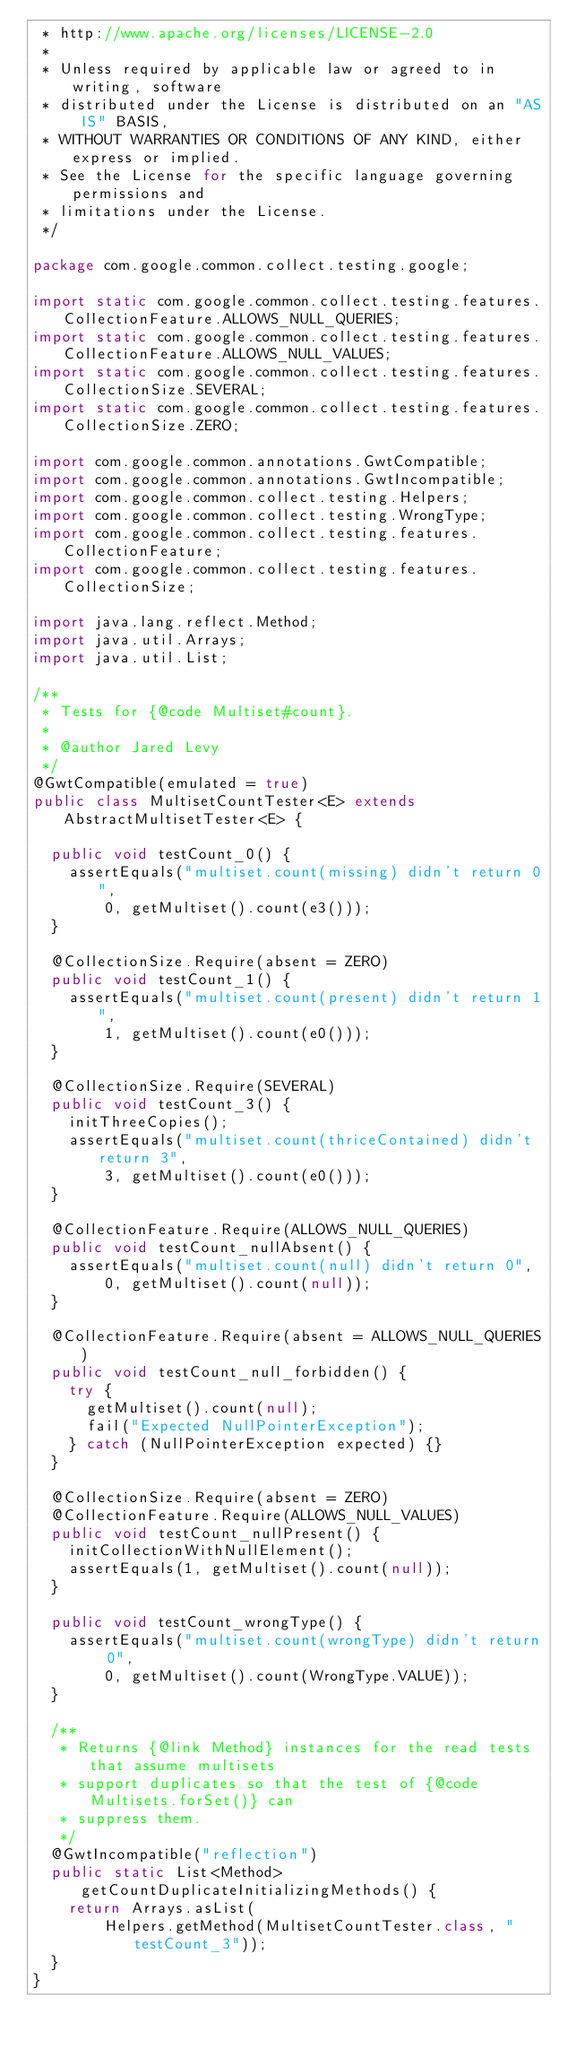Convert code to text. <code><loc_0><loc_0><loc_500><loc_500><_Java_> * http://www.apache.org/licenses/LICENSE-2.0
 *
 * Unless required by applicable law or agreed to in writing, software
 * distributed under the License is distributed on an "AS IS" BASIS,
 * WITHOUT WARRANTIES OR CONDITIONS OF ANY KIND, either express or implied.
 * See the License for the specific language governing permissions and
 * limitations under the License.
 */

package com.google.common.collect.testing.google;

import static com.google.common.collect.testing.features.CollectionFeature.ALLOWS_NULL_QUERIES;
import static com.google.common.collect.testing.features.CollectionFeature.ALLOWS_NULL_VALUES;
import static com.google.common.collect.testing.features.CollectionSize.SEVERAL;
import static com.google.common.collect.testing.features.CollectionSize.ZERO;

import com.google.common.annotations.GwtCompatible;
import com.google.common.annotations.GwtIncompatible;
import com.google.common.collect.testing.Helpers;
import com.google.common.collect.testing.WrongType;
import com.google.common.collect.testing.features.CollectionFeature;
import com.google.common.collect.testing.features.CollectionSize;

import java.lang.reflect.Method;
import java.util.Arrays;
import java.util.List;

/**
 * Tests for {@code Multiset#count}.
 *
 * @author Jared Levy
 */
@GwtCompatible(emulated = true)
public class MultisetCountTester<E> extends AbstractMultisetTester<E> {

  public void testCount_0() {
    assertEquals("multiset.count(missing) didn't return 0",
        0, getMultiset().count(e3()));
  }

  @CollectionSize.Require(absent = ZERO)
  public void testCount_1() {
    assertEquals("multiset.count(present) didn't return 1",
        1, getMultiset().count(e0()));
  }

  @CollectionSize.Require(SEVERAL)
  public void testCount_3() {
    initThreeCopies();
    assertEquals("multiset.count(thriceContained) didn't return 3",
        3, getMultiset().count(e0()));
  }

  @CollectionFeature.Require(ALLOWS_NULL_QUERIES)
  public void testCount_nullAbsent() {
    assertEquals("multiset.count(null) didn't return 0",
        0, getMultiset().count(null));
  }

  @CollectionFeature.Require(absent = ALLOWS_NULL_QUERIES)
  public void testCount_null_forbidden() {
    try {
      getMultiset().count(null);
      fail("Expected NullPointerException");
    } catch (NullPointerException expected) {}
  }
  
  @CollectionSize.Require(absent = ZERO)
  @CollectionFeature.Require(ALLOWS_NULL_VALUES)
  public void testCount_nullPresent() {
    initCollectionWithNullElement();
    assertEquals(1, getMultiset().count(null));
  }

  public void testCount_wrongType() {
    assertEquals("multiset.count(wrongType) didn't return 0",
        0, getMultiset().count(WrongType.VALUE));
  }

  /**
   * Returns {@link Method} instances for the read tests that assume multisets
   * support duplicates so that the test of {@code Multisets.forSet()} can
   * suppress them.
   */
  @GwtIncompatible("reflection")
  public static List<Method> getCountDuplicateInitializingMethods() {
    return Arrays.asList(
        Helpers.getMethod(MultisetCountTester.class, "testCount_3"));
  }
}
</code> 